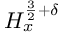Convert formula to latex. <formula><loc_0><loc_0><loc_500><loc_500>H _ { x } ^ { \frac { 3 } { 2 } + \delta }</formula> 